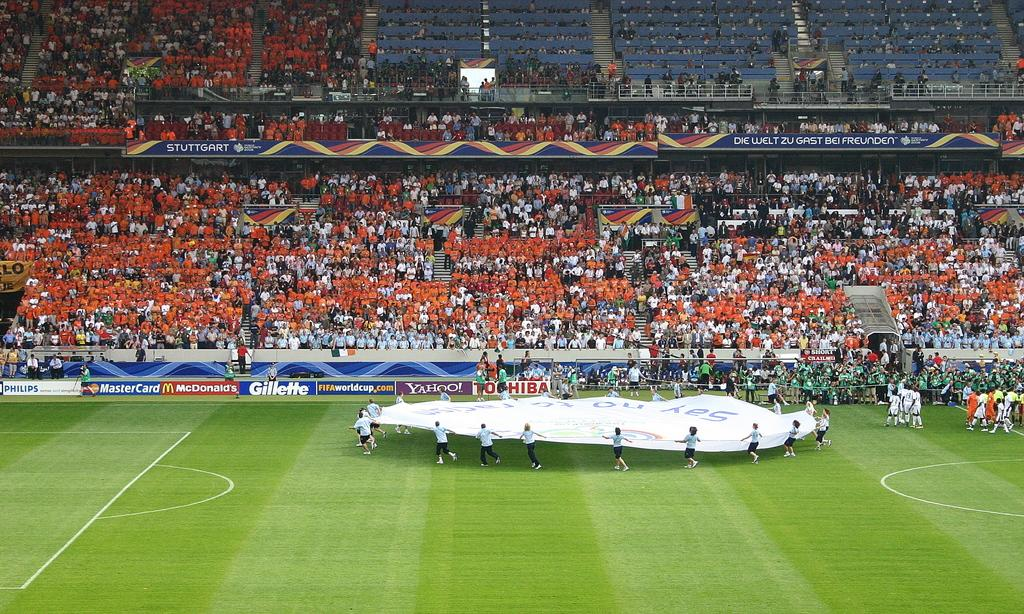<image>
Present a compact description of the photo's key features. Gillette is among the many advertisers for this game. 